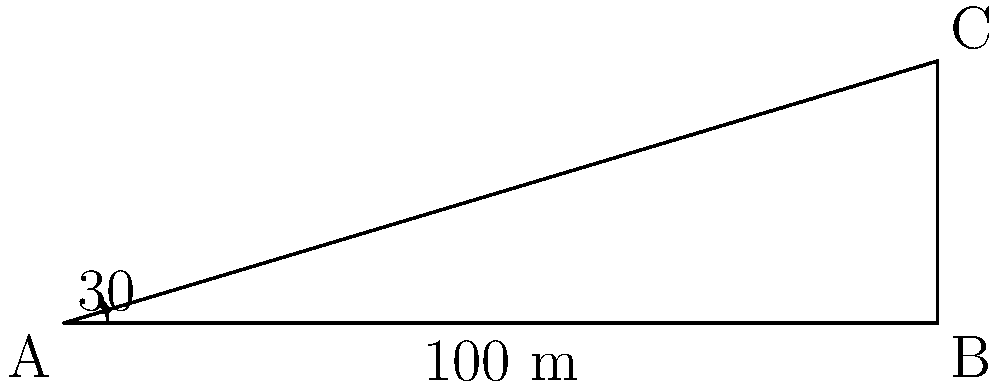A new government building is being proposed, and you need to determine its height for zoning regulations. From a point A on the ground, the angle of elevation to the top of the building (point C) is 30°. The distance from point A to the base of the building (point B) is 100 meters. Calculate the height of the proposed building. Let's approach this step-by-step using trigonometry:

1) We have a right-angled triangle ABC, where:
   - A is the observation point
   - B is the base of the building
   - C is the top of the building

2) We know:
   - The angle of elevation at A is 30°
   - The distance AB (adjacent to the angle) is 100 meters

3) We need to find BC, which is the height of the building (opposite to the angle)

4) In a right-angled triangle, we can use the tangent function:

   $\tan \theta = \frac{\text{opposite}}{\text{adjacent}}$

5) Substituting our known values:

   $\tan 30° = \frac{\text{height}}{100}$

6) We know that $\tan 30° = \frac{1}{\sqrt{3}}$, so:

   $\frac{1}{\sqrt{3}} = \frac{\text{height}}{100}$

7) Cross multiply:

   $100 \cdot \frac{1}{\sqrt{3}} = \text{height}$

8) Simplify:

   $\frac{100}{\sqrt{3}} = \text{height}$

9) To rationalize the denominator:

   $\frac{100}{\sqrt{3}} \cdot \frac{\sqrt{3}}{\sqrt{3}} = \frac{100\sqrt{3}}{3} \approx 57.74$ meters

Therefore, the height of the proposed government building is approximately 57.74 meters.
Answer: $\frac{100\sqrt{3}}{3}$ meters (≈ 57.74 meters) 